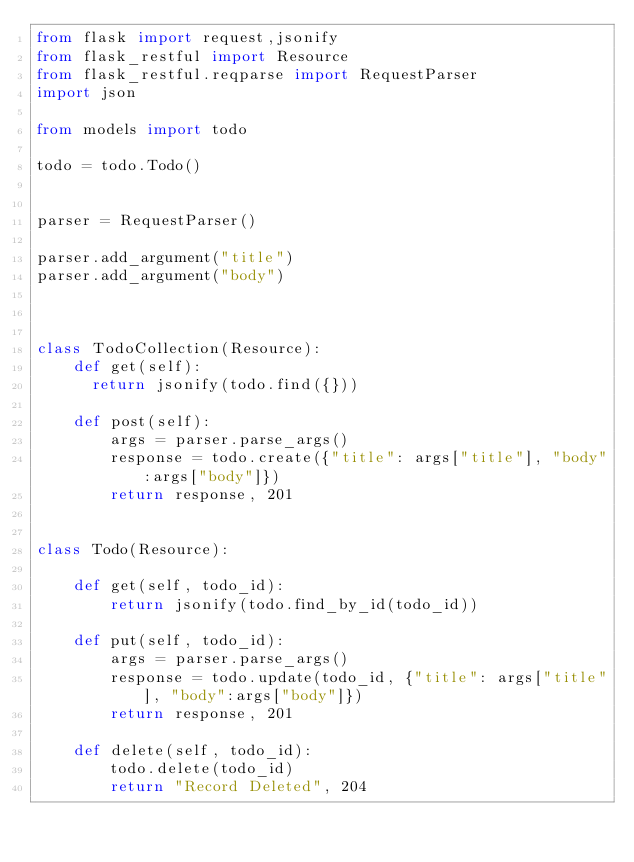<code> <loc_0><loc_0><loc_500><loc_500><_Python_>from flask import request,jsonify
from flask_restful import Resource
from flask_restful.reqparse import RequestParser
import json

from models import todo

todo = todo.Todo()


parser = RequestParser()

parser.add_argument("title")
parser.add_argument("body")



class TodoCollection(Resource):
    def get(self):
     	return jsonify(todo.find({}))  

    def post(self):
        args = parser.parse_args()
        response = todo.create({"title": args["title"], "body":args["body"]})
        return response, 201


class Todo(Resource):

    def get(self, todo_id):
        return jsonify(todo.find_by_id(todo_id))

    def put(self, todo_id):
        args = parser.parse_args()
        response = todo.update(todo_id, {"title": args["title"], "body":args["body"]})
        return response, 201

    def delete(self, todo_id):
        todo.delete(todo_id)
        return "Record Deleted", 204
</code> 